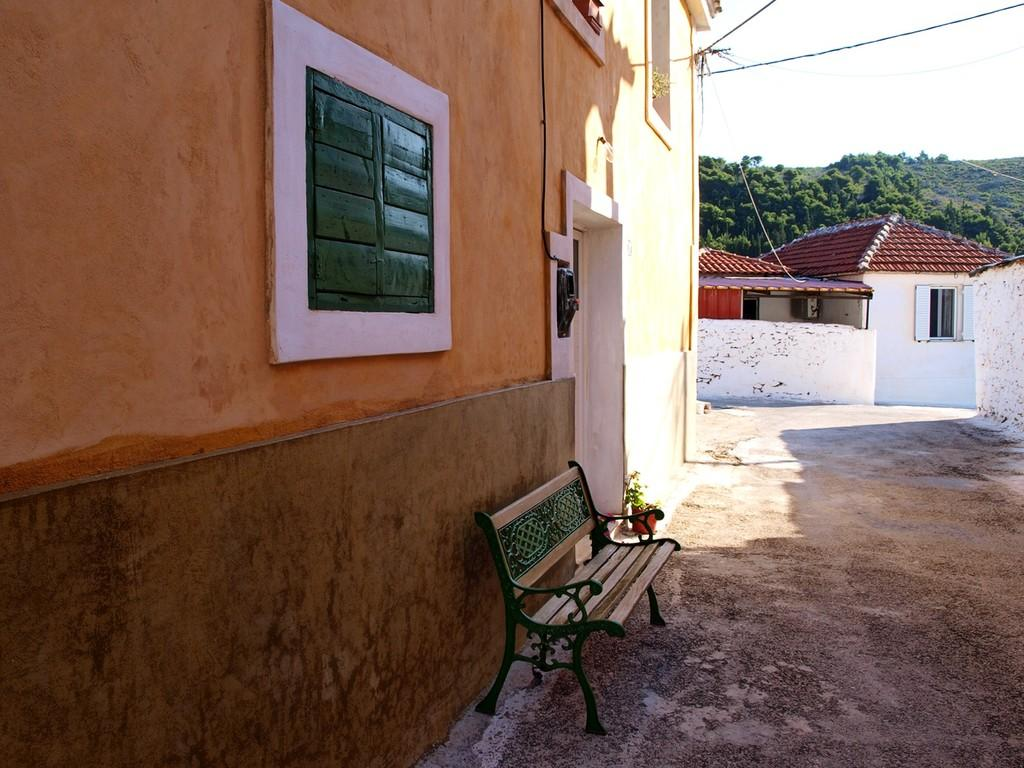What type of structure is present in the image? There is a building in the image. What type of seating is available in the image? There is a bench in the image. What type of container for plants is present in the image? There is a flower pot in the image. How many houses are visible in the image? There are two houses in the image. What type of vegetation can be seen in the background of the image? There are trees in the background of the image. What type of zipper can be seen on the trees in the image? There are no zippers present on the trees in the image. What sense is being stimulated by the chalk in the image? There is no chalk present in the image, so no sense is being stimulated by it. 